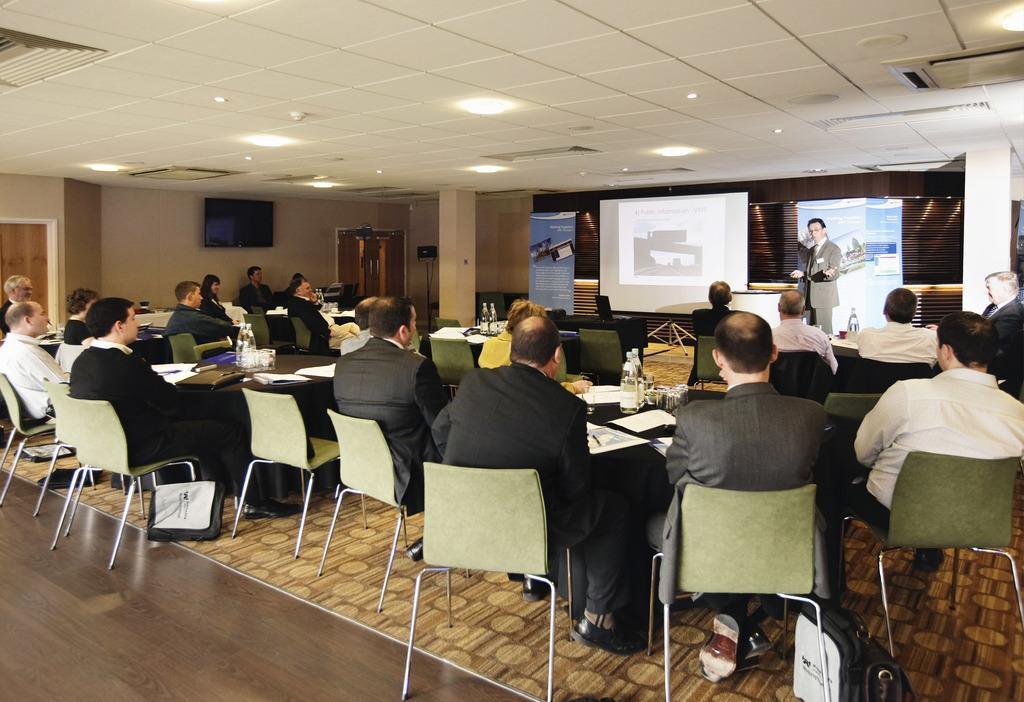In one or two sentences, can you explain what this image depicts? In this image I can see the group of people sitting on the chairs. In front of them one person is standing. To the side of him there is a screen and the banner. 